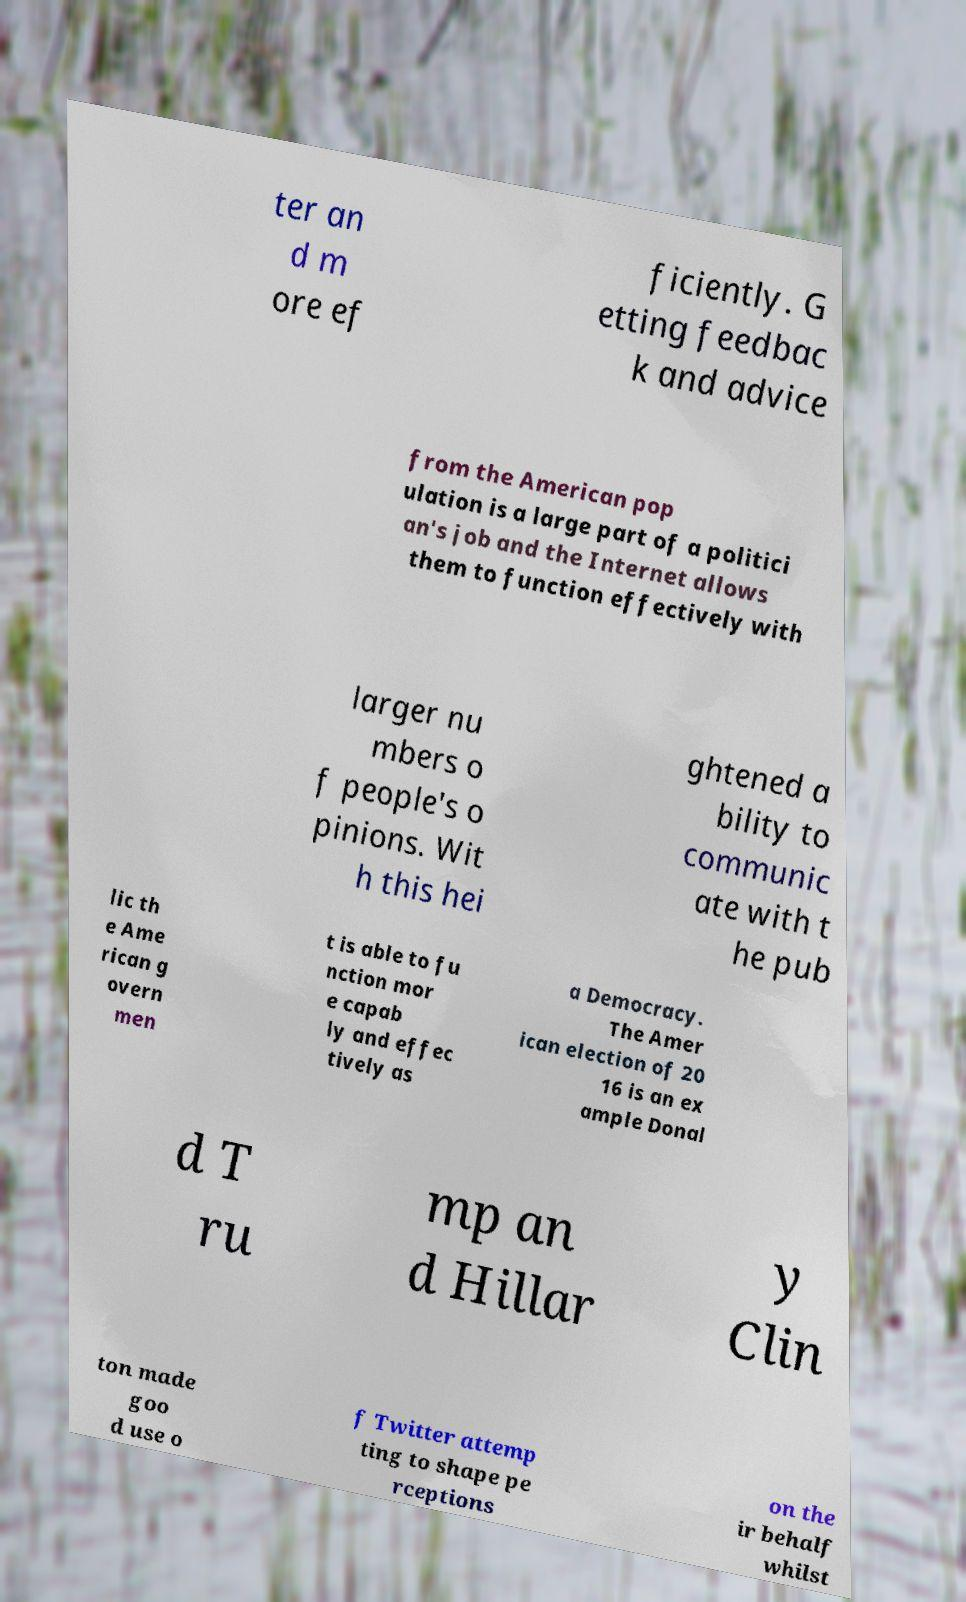I need the written content from this picture converted into text. Can you do that? ter an d m ore ef ficiently. G etting feedbac k and advice from the American pop ulation is a large part of a politici an's job and the Internet allows them to function effectively with larger nu mbers o f people's o pinions. Wit h this hei ghtened a bility to communic ate with t he pub lic th e Ame rican g overn men t is able to fu nction mor e capab ly and effec tively as a Democracy. The Amer ican election of 20 16 is an ex ample Donal d T ru mp an d Hillar y Clin ton made goo d use o f Twitter attemp ting to shape pe rceptions on the ir behalf whilst 